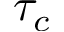Convert formula to latex. <formula><loc_0><loc_0><loc_500><loc_500>\tau _ { c }</formula> 